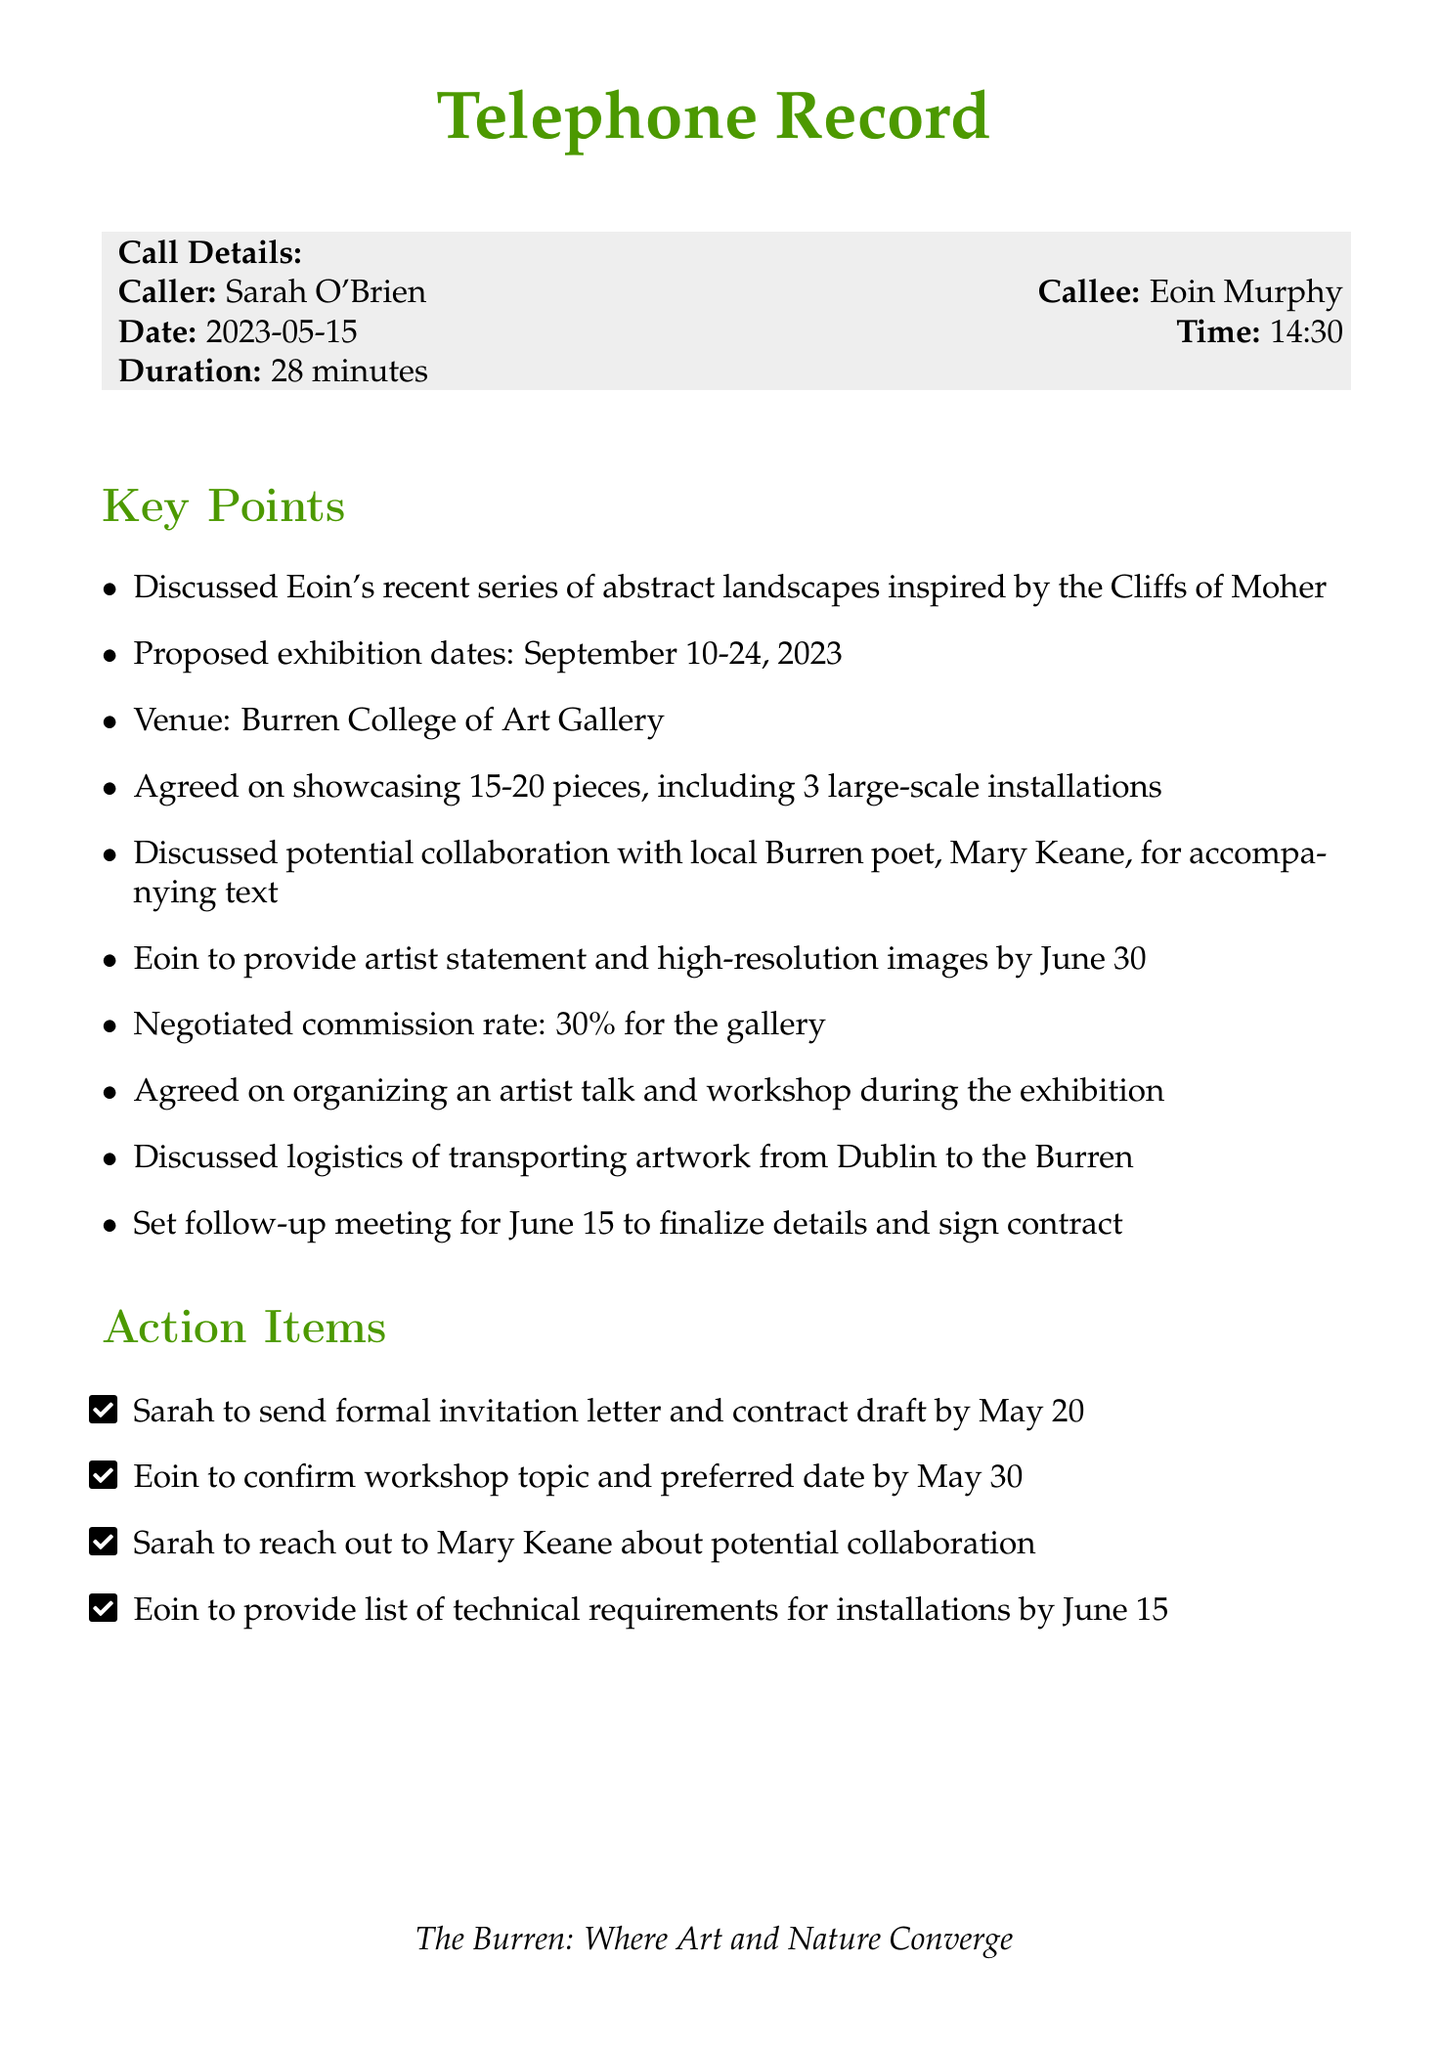What is the name of the caller? The caller's name is explicitly stated at the beginning of the document.
Answer: Sarah O'Brien Who is the artist discussed in the conversation? The callee, who is the artist being discussed, is mentioned in the call details.
Answer: Eoin Murphy What is the proposed exhibition date? The date range for the proposed exhibition is given in the key points section.
Answer: September 10-24, 2023 How many pieces are agreed to be showcased? The number of pieces to be showcased is specified in the key points list.
Answer: 15-20 pieces What is the commission rate for the gallery? The document mentions the negotiated commission rate for the gallery within the key points.
Answer: 30% Who will accompany the exhibition with text? The potential collaboration for accompanying text is outlined in the key points.
Answer: Mary Keane When is the follow-up meeting scheduled? The date for the follow-up meeting is provided in the action items section.
Answer: June 15 What is the venue for the exhibition? The venue for the planned exhibition is clearly mentioned in the key points.
Answer: Burren College of Art Gallery What will Eoin provide by June 30? The action item specifies what Eoin is expected to provide by the given date.
Answer: Artist statement and high-resolution images What topic will Eoin confirm by May 30? The action item requires Eoin to confirm a specific topic related to the exhibition.
Answer: Workshop topic 